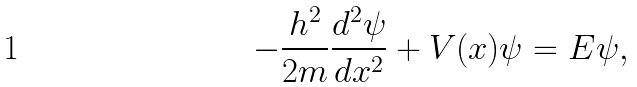Convert formula to latex. <formula><loc_0><loc_0><loc_500><loc_500>- \frac { h ^ { 2 } } { 2 m } \frac { d ^ { 2 } \psi } { d x ^ { 2 } } + V ( x ) \psi = E \psi ,</formula> 